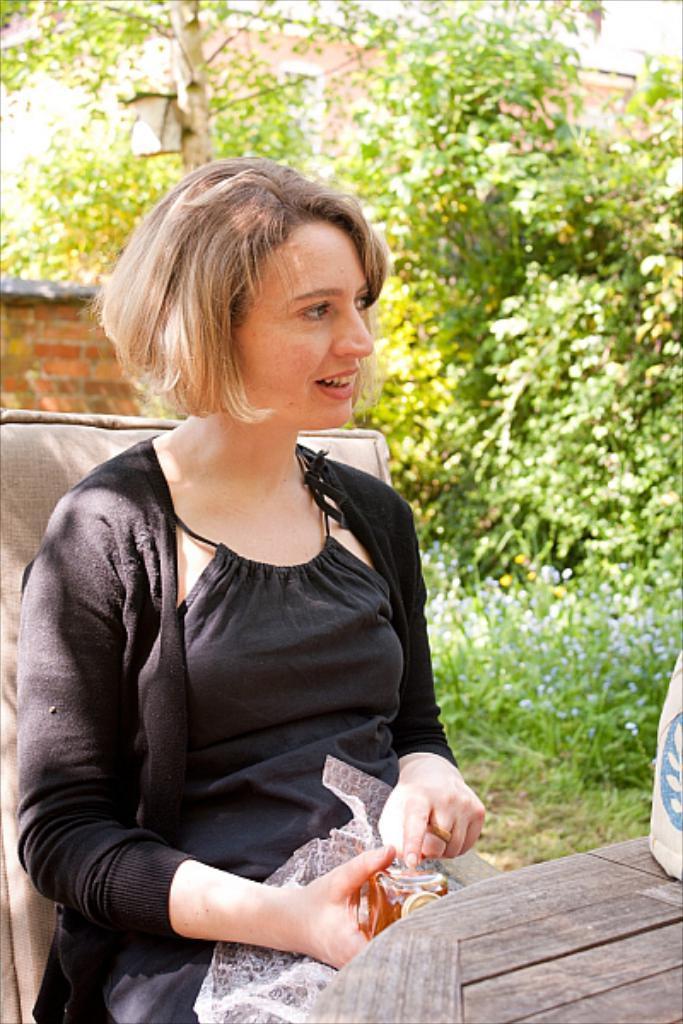Can you describe this image briefly? In this image in the front there is a table and on the table there is an object which is brown in colour. In the center there is a woman sitting on a chair and smiling and holding an object in her hand. In the background there are trees and there's grass on the ground and there is a building. 